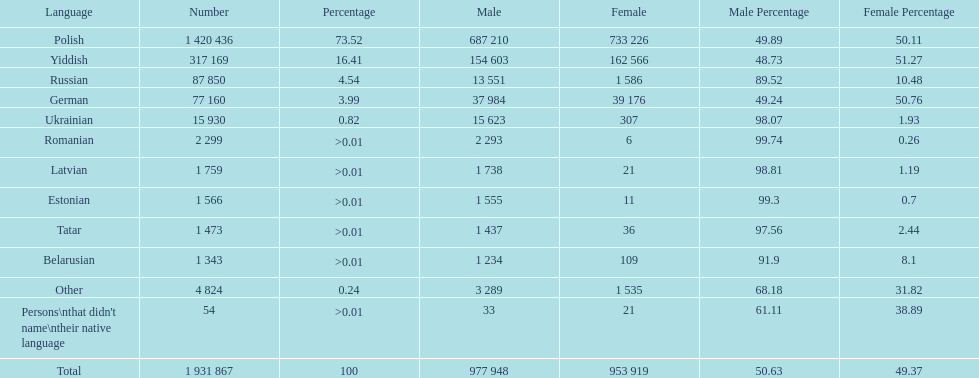Number of male russian speakers 13 551. 